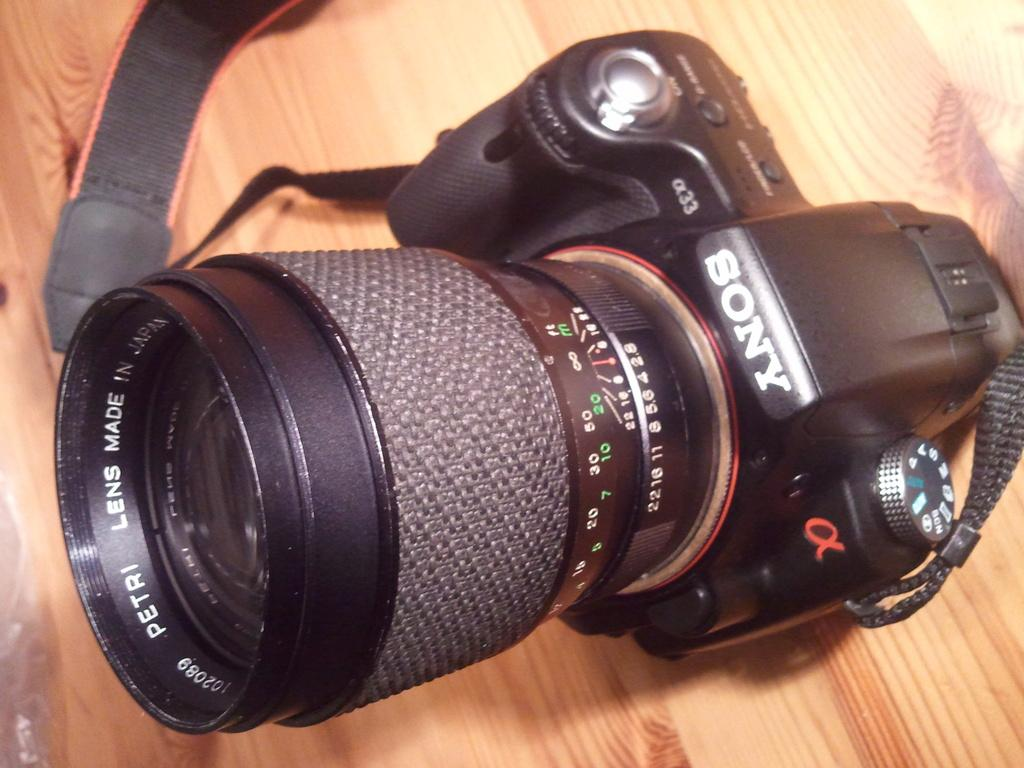What object is the main focus of the image? There is a camera in the image. Where is the camera placed in the image? The camera is on a wooden surface. What type of net is being used to capture the camera in the image? There is no net present in the image, and the camera is not being captured. 